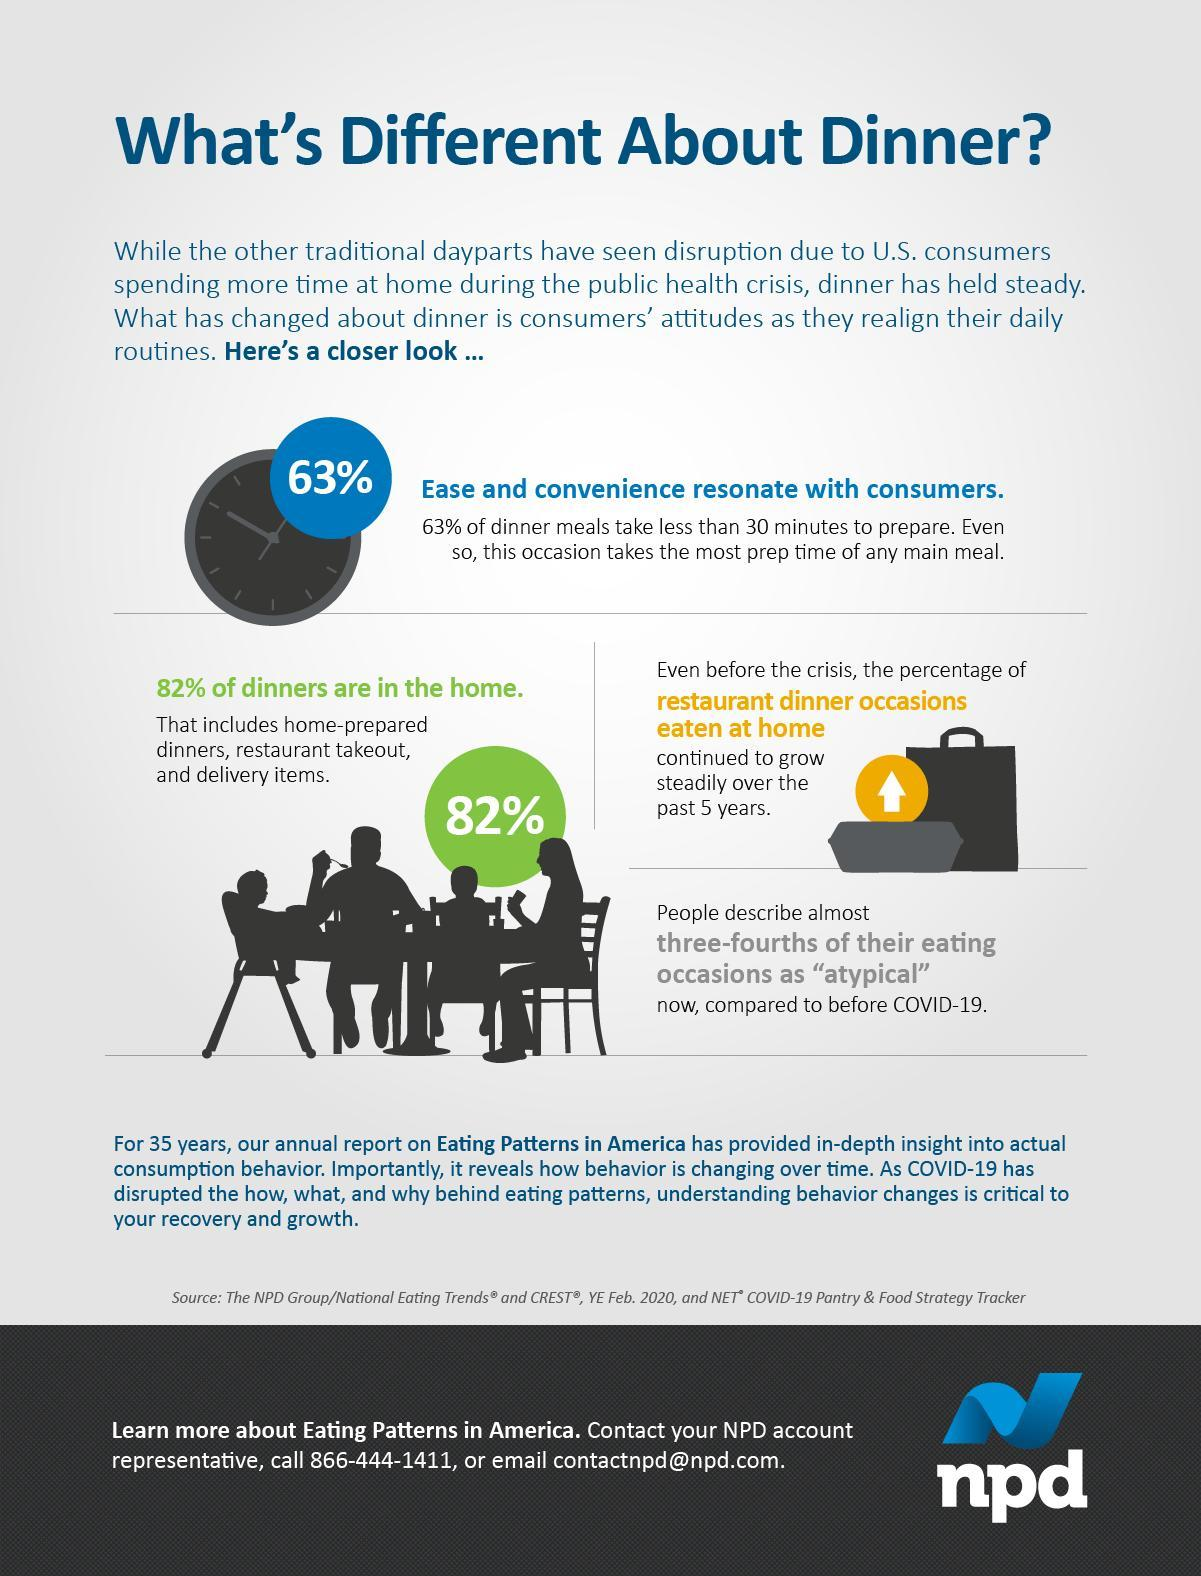Which meal take most preparation time of any meal?
Answer the question with a short phrase. dinner meal What has grown steadily over past 5 years? restaurant dinner occasions eaten at home What does dinners consumed at home include? home-prepared dinners, restaurant takeout, and delivery items What meal can be prepared in less than half an hour? dinner meals 